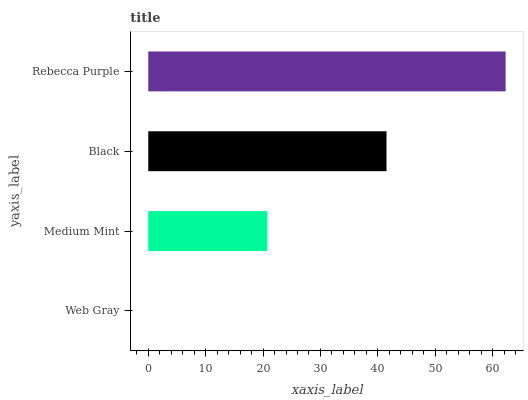Is Web Gray the minimum?
Answer yes or no. Yes. Is Rebecca Purple the maximum?
Answer yes or no. Yes. Is Medium Mint the minimum?
Answer yes or no. No. Is Medium Mint the maximum?
Answer yes or no. No. Is Medium Mint greater than Web Gray?
Answer yes or no. Yes. Is Web Gray less than Medium Mint?
Answer yes or no. Yes. Is Web Gray greater than Medium Mint?
Answer yes or no. No. Is Medium Mint less than Web Gray?
Answer yes or no. No. Is Black the high median?
Answer yes or no. Yes. Is Medium Mint the low median?
Answer yes or no. Yes. Is Medium Mint the high median?
Answer yes or no. No. Is Rebecca Purple the low median?
Answer yes or no. No. 